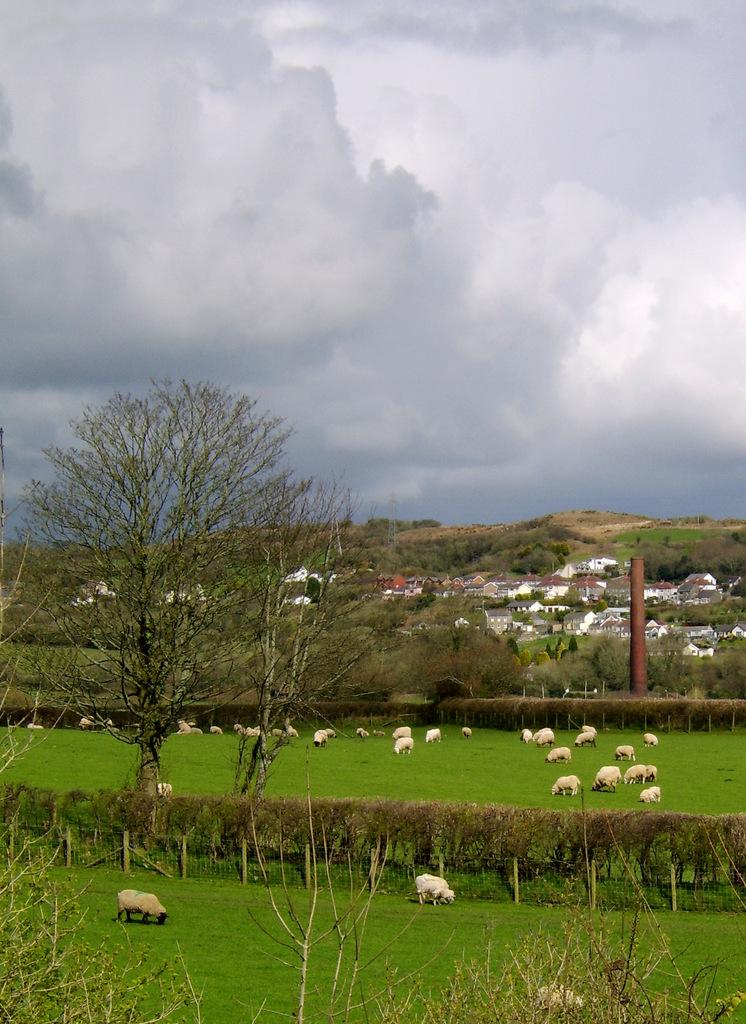What type of vegetation can be seen in the front of the image? There are trees, grass, and plants in the front of the image. What other elements can be seen in the front of the image? There are animals, houses, and railings in the front of the image. What objects are present in the front of the image? There are objects in the front of the image, but their specific nature is not mentioned in the facts. What can be seen in the background of the image? The sky is visible in the background of the image. What is the condition of the sky in the image? The sky is cloudy in the image. How many legs does the sister have in the image? There is no mention of a sister or legs in the image, so this question cannot be answered. 